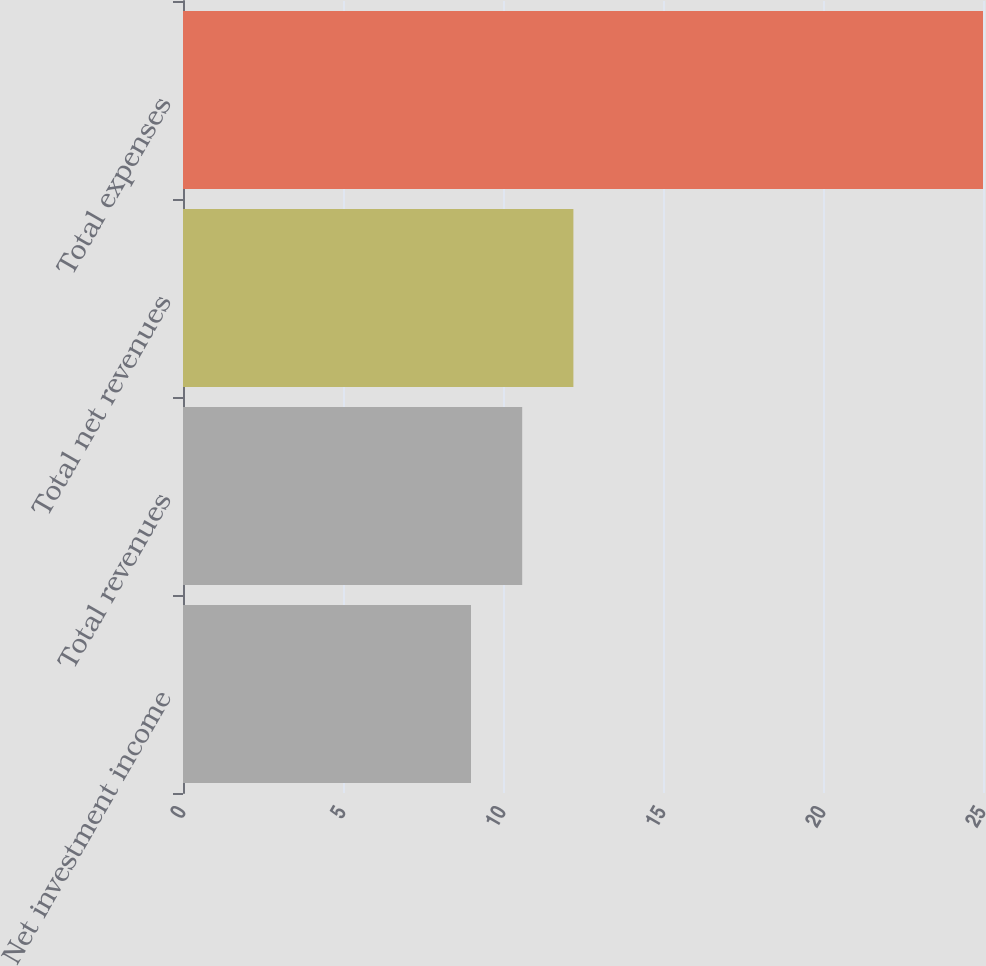Convert chart to OTSL. <chart><loc_0><loc_0><loc_500><loc_500><bar_chart><fcel>Net investment income<fcel>Total revenues<fcel>Total net revenues<fcel>Total expenses<nl><fcel>9<fcel>10.6<fcel>12.2<fcel>25<nl></chart> 